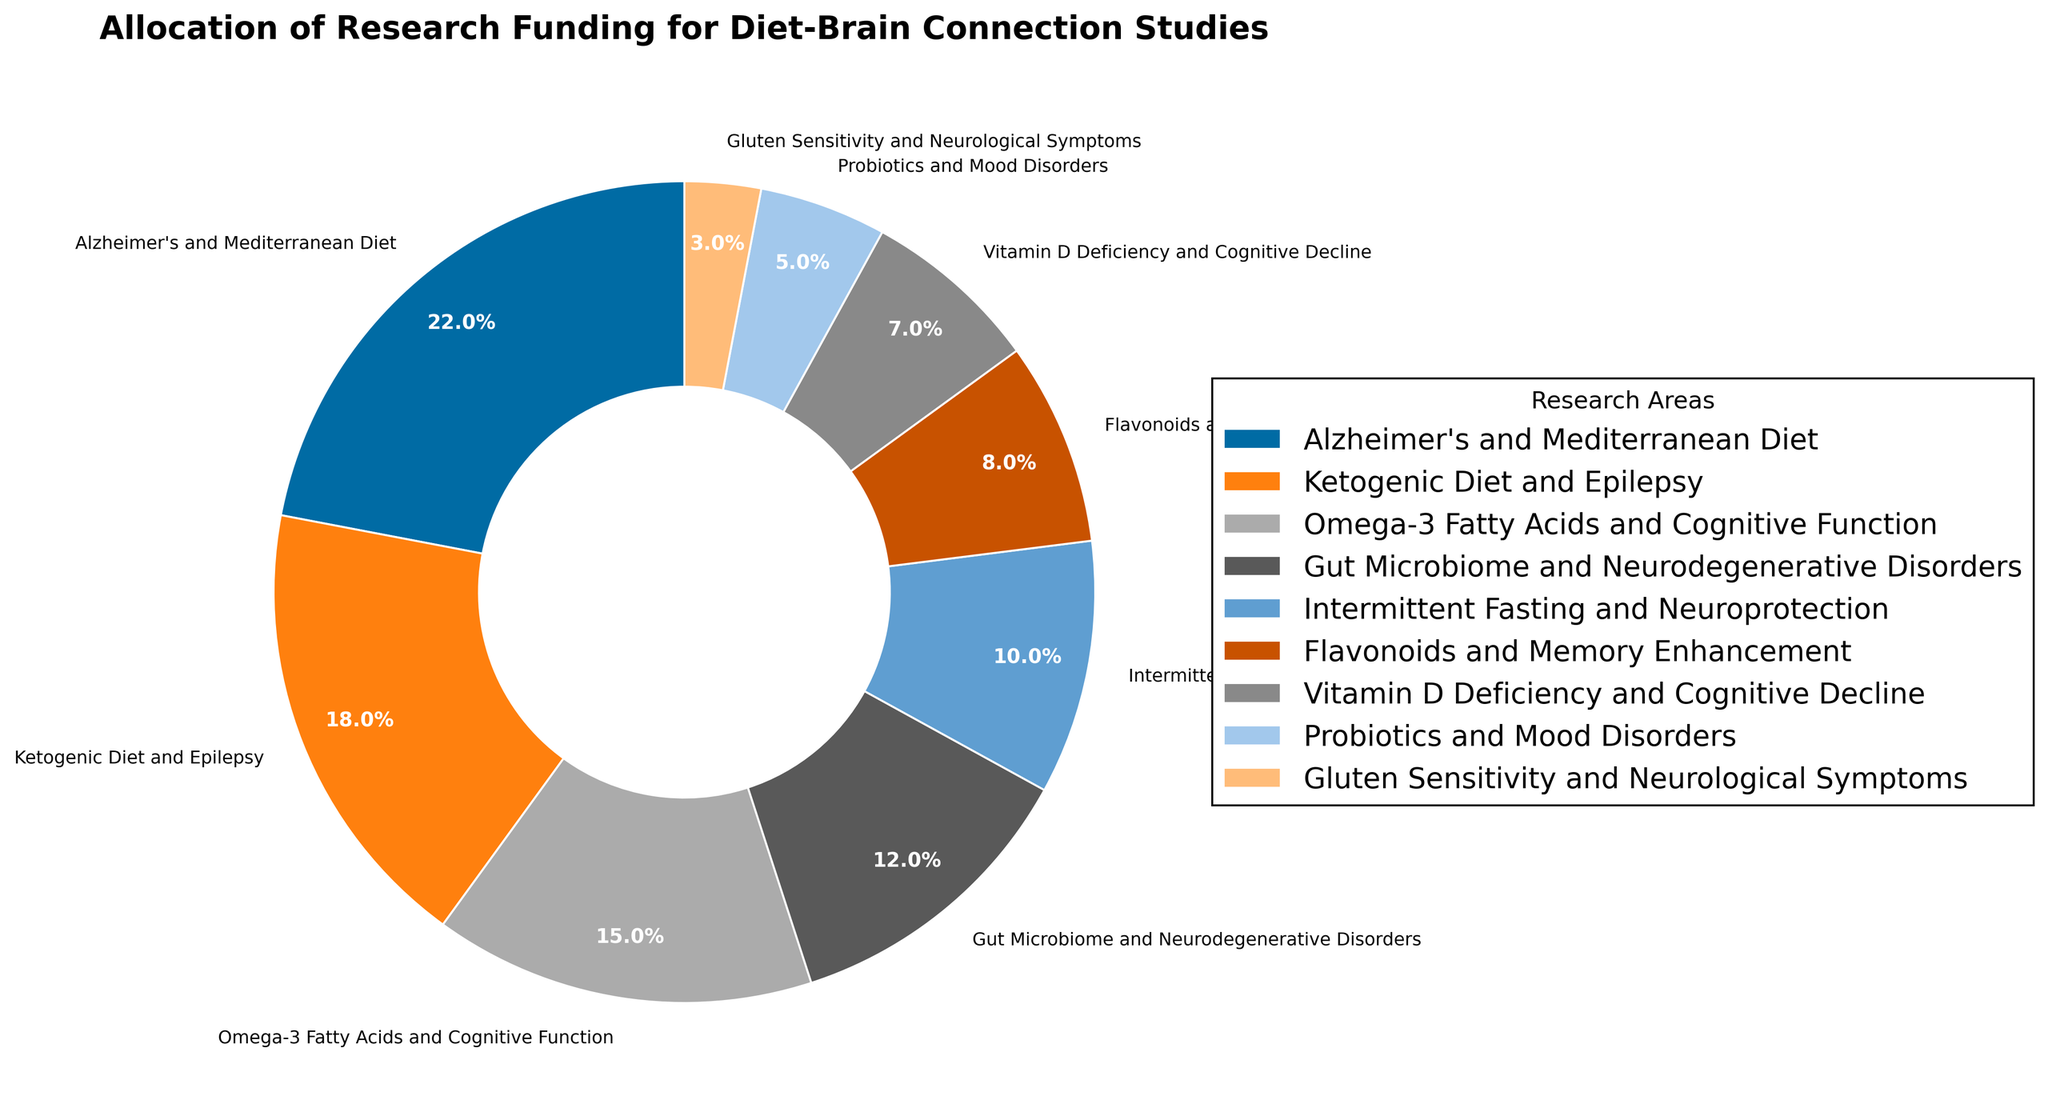What is the funding percentage allocated to Alzheimer's and Mediterranean Diet studies? The pie chart segment labeled "Alzheimer's and Mediterranean Diet" indicates a funding percentage of 22%.
Answer: 22% Which research area receives the least funding, and what is its percentage? The smallest pie chart segment is labeled "Gluten Sensitivity and Neurological Symptoms," indicating a funding percentage of 3%.
Answer: Gluten Sensitivity and Neurological Symptoms, 3% How much more funding percentage does the Alzheimer's and Mediterranean Diet receive compared to the Probiotics and Mood Disorders? Alzheimer's and Mediterranean Diet receives 22%, and Probiotics and Mood Disorders receive 5%. The difference is 22% - 5% = 17%.
Answer: 17% Which research area receives the highest funding, and which receives the second highest? The largest segment in the pie chart is labeled "Alzheimer's and Mediterranean Diet" with 22%, and the second largest is "Ketogenic Diet and Epilepsy" with 18%.
Answer: Alzheimer's and Mediterranean Diet, Ketogenic Diet and Epilepsy Calculate the total funding percentage allocated to studies related to diet and cognitive function (sum of Alzheimer's and Mediterranean Diet, Omega-3 Fatty Acids and Cognitive Function, and Flavonoids and Memory Enhancement). The funding percentages for these areas are 22% (Alzheimer's and Mediterranean Diet), 15% (Omega-3 Fatty Acids and Cognitive Function), and 8% (Flavonoids and Memory Enhancement). The total is 22% + 15% + 8% = 45%.
Answer: 45% How many research areas receive a funding percentage less than 10%? By visual inspection, the segments with less than 10% are "Flavonoids and Memory Enhancement" (8%), "Vitamin D Deficiency and Cognitive Decline" (7%), "Probiotics and Mood Disorders" (5%), and "Gluten Sensitivity and Neurological Symptoms" (3%). There are 4 such areas.
Answer: 4 What is the total funding percentage for all research areas related to specific types of diets (Mediterranean Diet, Ketogenic Diet, Intermittent Fasting)? The relevant percentages are 22% (Alzheimer's and Mediterranean Diet), 18% (Ketogenic Diet and Epilepsy), and 10% (Intermittent Fasting and Neuroprotection). The total is 22% + 18% + 10% = 50%.
Answer: 50% Is the funding for Gut Microbiome and Neurodegenerative Disorders higher or lower than that for Omega-3 Fatty Acids and Cognitive Function, and by how much? Gut Microbiome and Neurodegenerative Disorders have 12% funding, while Omega-3 Fatty Acids and Cognitive Function have 15%. The difference is 15% - 12% = 3%, with Omega-3 Fatty Acids and Cognitive Function receiving more.
Answer: Lower, by 3% Which research areas have funding percentages within 2% of each other? The funding percentages for "Gut Microbiome and Neurodegenerative Disorders" (12%) and "Intermittent Fasting and Neuroprotection" (10%) are within 2% of each other. Additionally, "Vitamin D Deficiency and Cognitive Decline" (7%) and "Probiotics and Mood Disorders" (5%) are also within 2% of each other.
Answer: Gut Microbiome and Neurodegenerative Disorders with Intermittent Fasting and Neuroprotection, Vitamin D Deficiency and Cognitive Decline with Probiotics and Mood Disorders 